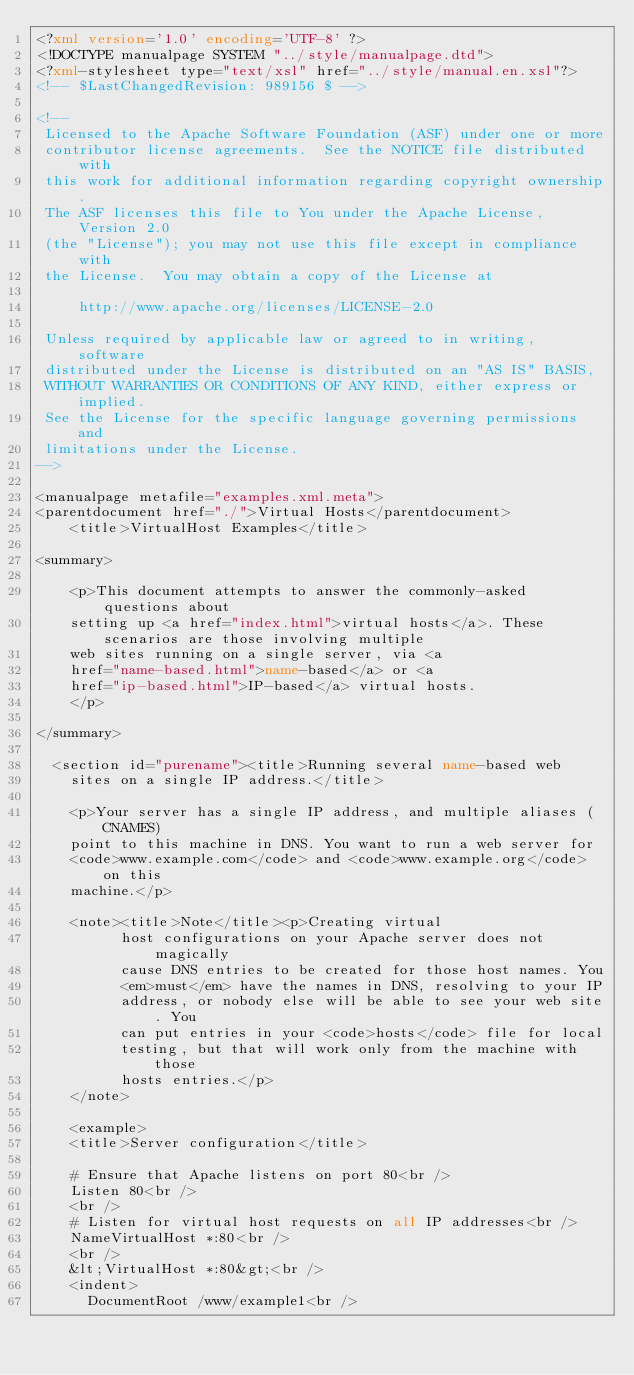<code> <loc_0><loc_0><loc_500><loc_500><_XML_><?xml version='1.0' encoding='UTF-8' ?>
<!DOCTYPE manualpage SYSTEM "../style/manualpage.dtd">
<?xml-stylesheet type="text/xsl" href="../style/manual.en.xsl"?>
<!-- $LastChangedRevision: 989156 $ -->

<!--
 Licensed to the Apache Software Foundation (ASF) under one or more
 contributor license agreements.  See the NOTICE file distributed with
 this work for additional information regarding copyright ownership.
 The ASF licenses this file to You under the Apache License, Version 2.0
 (the "License"); you may not use this file except in compliance with
 the License.  You may obtain a copy of the License at

     http://www.apache.org/licenses/LICENSE-2.0

 Unless required by applicable law or agreed to in writing, software
 distributed under the License is distributed on an "AS IS" BASIS,
 WITHOUT WARRANTIES OR CONDITIONS OF ANY KIND, either express or implied.
 See the License for the specific language governing permissions and
 limitations under the License.
-->

<manualpage metafile="examples.xml.meta">
<parentdocument href="./">Virtual Hosts</parentdocument>
    <title>VirtualHost Examples</title>

<summary>

    <p>This document attempts to answer the commonly-asked questions about
    setting up <a href="index.html">virtual hosts</a>. These scenarios are those involving multiple
    web sites running on a single server, via <a
    href="name-based.html">name-based</a> or <a
    href="ip-based.html">IP-based</a> virtual hosts.
    </p>

</summary>

  <section id="purename"><title>Running several name-based web
    sites on a single IP address.</title>

    <p>Your server has a single IP address, and multiple aliases (CNAMES)
    point to this machine in DNS. You want to run a web server for
    <code>www.example.com</code> and <code>www.example.org</code> on this
    machine.</p>

    <note><title>Note</title><p>Creating virtual
          host configurations on your Apache server does not magically
          cause DNS entries to be created for those host names. You
          <em>must</em> have the names in DNS, resolving to your IP
          address, or nobody else will be able to see your web site. You
          can put entries in your <code>hosts</code> file for local
          testing, but that will work only from the machine with those
          hosts entries.</p>
    </note>

    <example>
    <title>Server configuration</title>

    # Ensure that Apache listens on port 80<br />
    Listen 80<br />
    <br />
    # Listen for virtual host requests on all IP addresses<br />
    NameVirtualHost *:80<br />
    <br />
    &lt;VirtualHost *:80&gt;<br />
    <indent>
      DocumentRoot /www/example1<br /></code> 